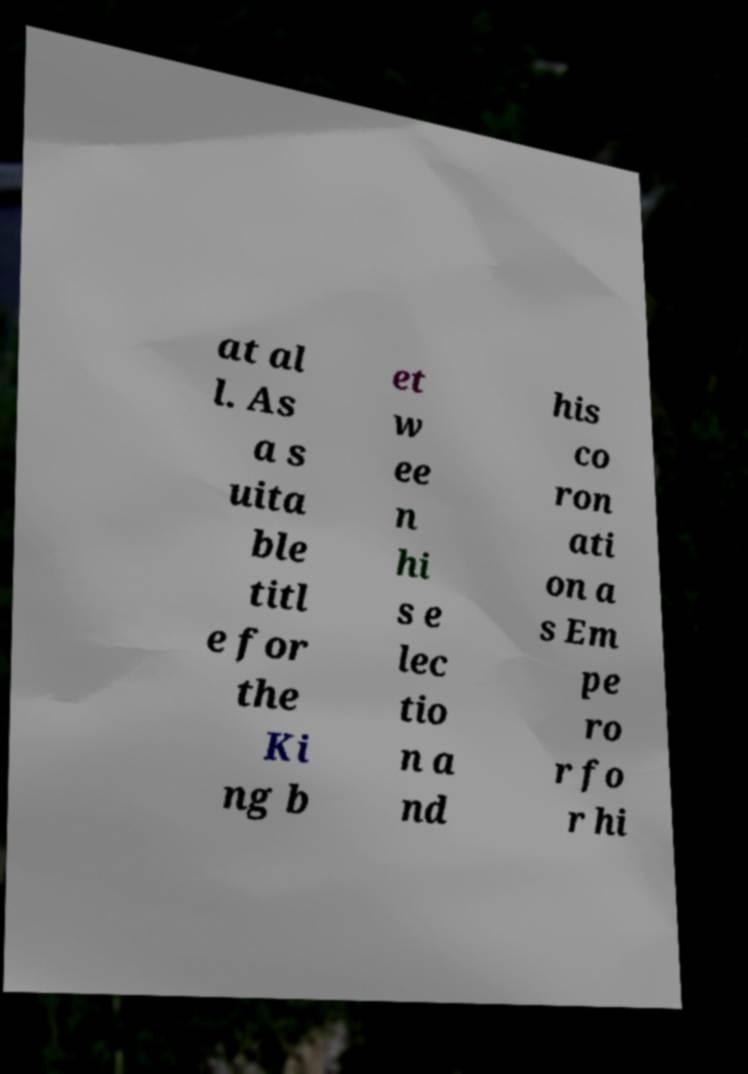Could you extract and type out the text from this image? at al l. As a s uita ble titl e for the Ki ng b et w ee n hi s e lec tio n a nd his co ron ati on a s Em pe ro r fo r hi 